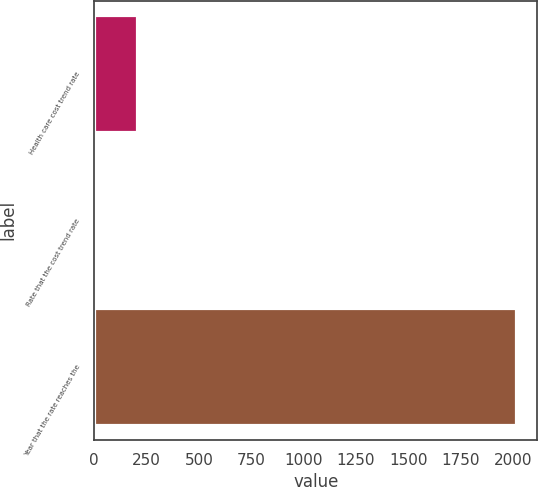Convert chart to OTSL. <chart><loc_0><loc_0><loc_500><loc_500><bar_chart><fcel>Health care cost trend rate<fcel>Rate that the cost trend rate<fcel>Year that the rate reaches the<nl><fcel>206.1<fcel>5<fcel>2016<nl></chart> 